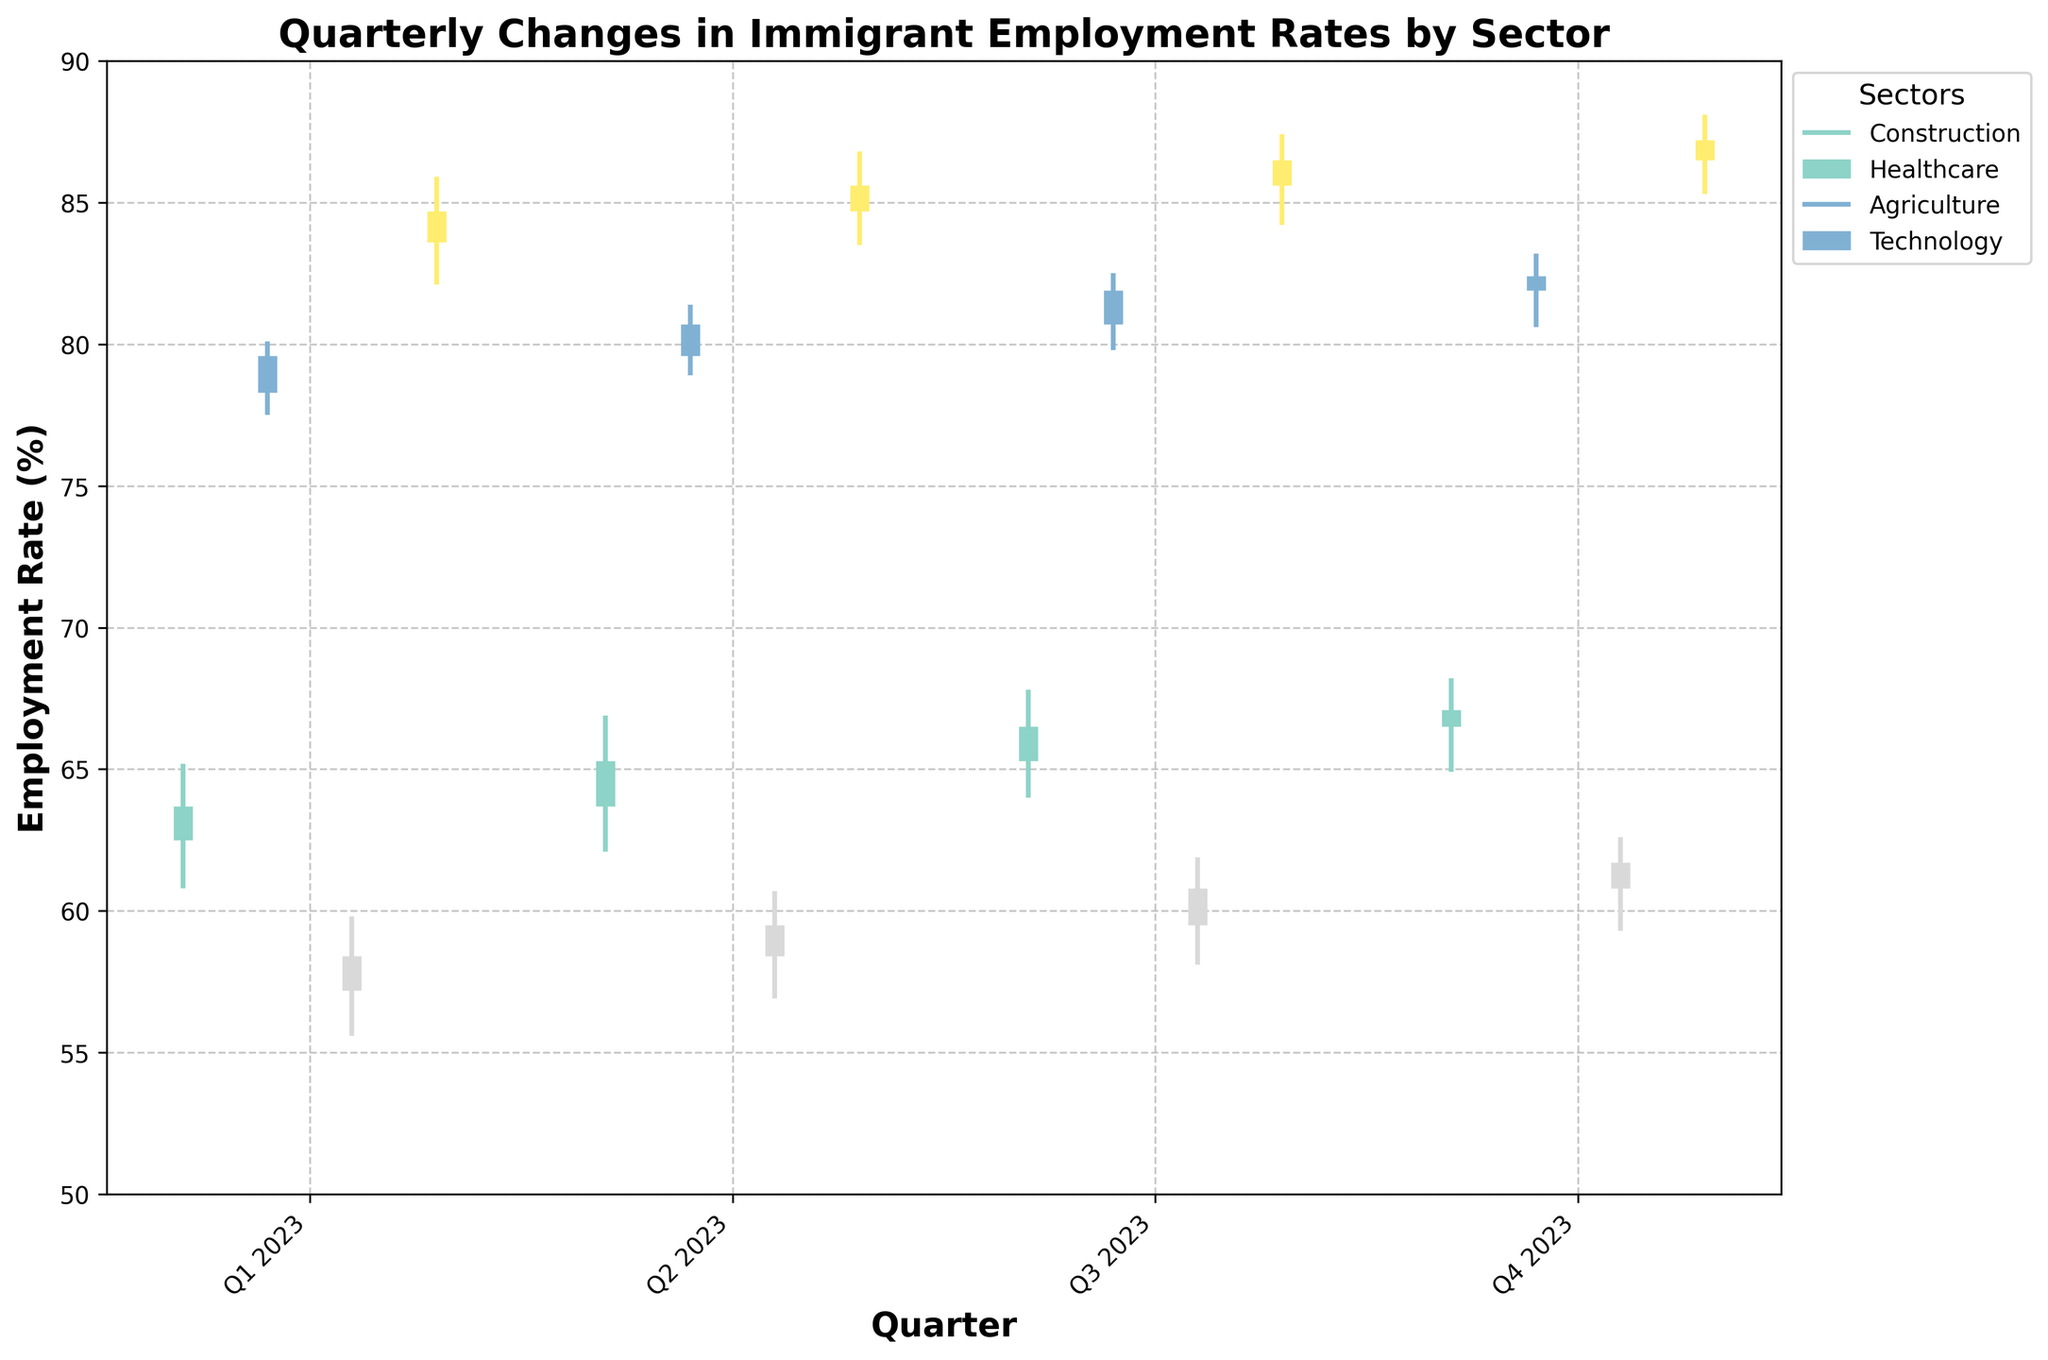How many sectors are represented in the chart? Identify the number of unique sectors listed in the legend. There are four sectors: Construction, Healthcare, Agriculture, and Technology.
Answer: 4 What is the highest employment rate reached in the Technology sector during 2023? Refer to the highest value of the vertical bars for the Technology sector. It peaks in Q4 2023 at 88.1%.
Answer: 88.1% Which sector had the lowest employment rate in Q1 2023? Look at the lowest value of the vertical bars for each sector in Q1 2023. Agriculture has the lowest with a value of 55.6%.
Answer: Agriculture Which quarter witnessed the highest closing employment rate in the Healthcare sector? Compare the 'Close' values for each quarter in the Healthcare sector. Q4 2023 has the highest 'Close' value at 82.4%.
Answer: Q4 2023 What is the average closing employment rate in the Construction sector for 2023? Sum the 'Close' values for all four quarters and divide by 4: (63.7 + 65.3 + 66.5 + 67.1) / 4 = 65.65.
Answer: 65.65 Which sectors saw an overall increase in employment rates from Q1 to Q4 2023? Compare the 'Open' value in Q1 2023 with the 'Close' value in Q4 2023 across sectors. All sectors show an increase: Construction (62.5 to 67.1), Healthcare (78.3 to 82.4), Agriculture (57.2 to 61.7), and Technology (83.6 to 87.2).
Answer: All sectors In which quarter did the Agriculture sector see the biggest increase in employment rates? Calculate the difference between 'Open' and 'Close' for each quarter in Agriculture. Q2 2023 has the largest increase: 59.5 - 58.4 = 1.1.
Answer: Q2 2023 Which sector had the most stable employment rates, considering the smallest range between the highest and lowest values in Q4 2023? Compare the range (High - Low) values for Q4 2023 in each sector. Construction has the smallest range: 68.2 - 64.9 = 3.3.
Answer: Construction 